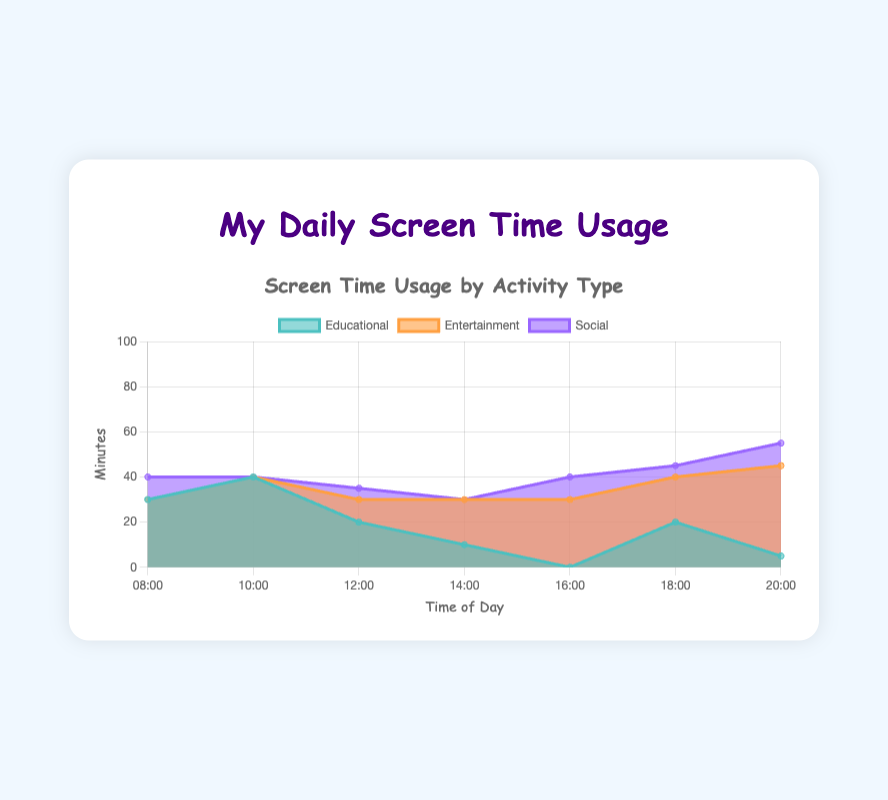What's the title of the chart? The title is usually located at the top of the chart. For this figure, it's provided in the code and displayed in a heading element.
Answer: My Daily Screen Time Usage What are the labels on the x-axis? The labels on the x-axis represent the times of day when screen usage is measured. Based on the data and code, they appear from 08:00 to 20:00.
Answer: 08:00, 10:00, 12:00, 14:00, 16:00, 18:00, 20:00 Which activity type has the highest usage at 20:00? To find the highest usage at 20:00, look at the values for each activity type at this time point. Educational is 5 minutes, Entertainment is 40 minutes, and Social is 10 minutes.
Answer: Entertainment At what time is educational usage the highest, and what is its value? By reviewing the educational data points, the highest value is at 10:00 with 40 minutes. No other data point for educational usage surpasses this value.
Answer: 10:00, 40 minutes What is the total screen time usage for all activities at 12:00? Summing the screen time for all activities at 12:00: Educational (20) + Entertainment (10) + Social (5) equals 35 minutes.
Answer: 35 minutes Between which two times does Entertainment usage see the largest increase? To determine the largest increase, compare consecutive increments in Entertainment usage: 0 (08:00) to 0 (10:00), no change; 0 (10:00) to 10 (12:00), an increase of 10; 10 (12:00) to 20 (14:00), an increase of 10; 20 (14:00) to 30 (16:00), an increase of 10; 30 (16:00) to 20 (18:00), a decrease. Considering the largest increase systematically shows from 16:00 to 18:00 by 10 minutes.
Answer: 16:00 to 18:00 How many data points are there for each activity type throughout the day? The chart's labels span seven time points from the data provided. Each activity type—Educational, Entertainment, and Social—thus has seven data points each.
Answer: 7 Which activity type shows the most consistent usage throughout the day? Reviewing the values: Educational has significant fluctuations (from 0 to 40), Entertainment varies (from 0 to 40), and Social has smaller changes (from 0 to 10). Social's values are more consistent with smaller variations.
Answer: Social How does the screen time change from 08:00 to 10:00 for all activities, combined? Calculate the combined screen time at 08:00: 30 (Educational) + 0 (Entertainment) + 10 (Social) equals 40 minutes. At 10:00, it's 40 (Educational) + 0 (Entertainment) + 0 (Social) equals 40 minutes. The screen time remains constant at 40 minutes.
Answer: No Change At what times is the Social screen time exactly 0? From the Social data values, the time points showing 0 minutes are at 10:00 and 14:00.
Answer: 10:00, 14:00 